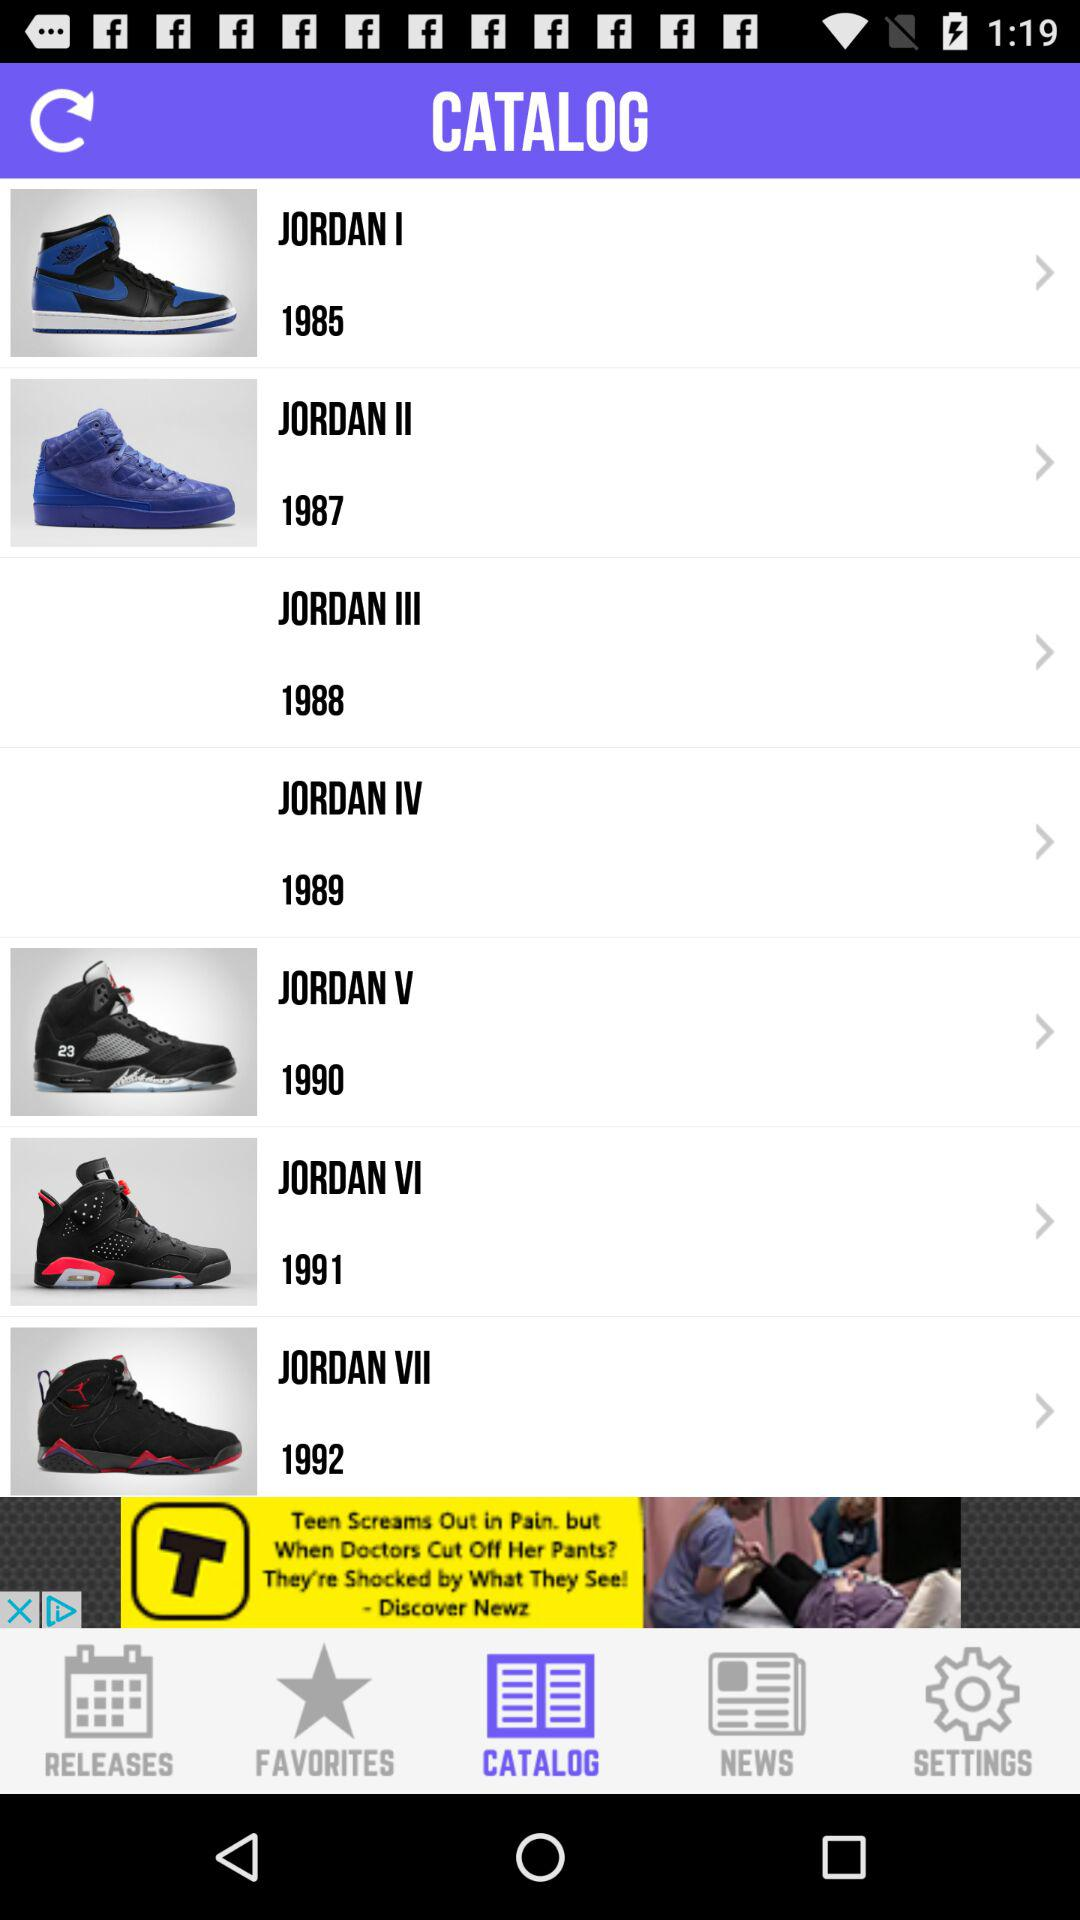When was the "JORDAN V" released? The "JORDAN V" was released in 1990. 